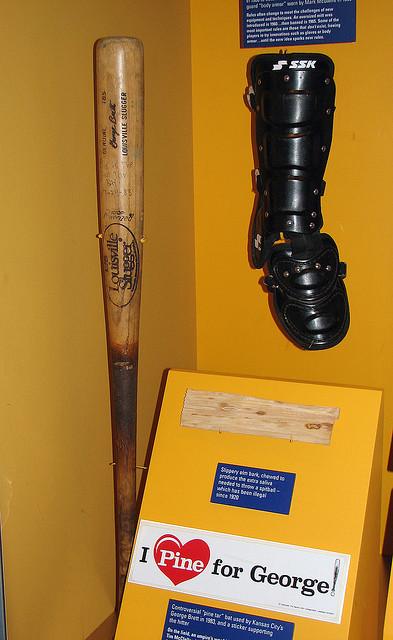What is the black item hanging upright?
Short answer required. Shin guard. Is there a bat here?
Write a very short answer. Yes. What is the person's name in the image?
Write a very short answer. George. 